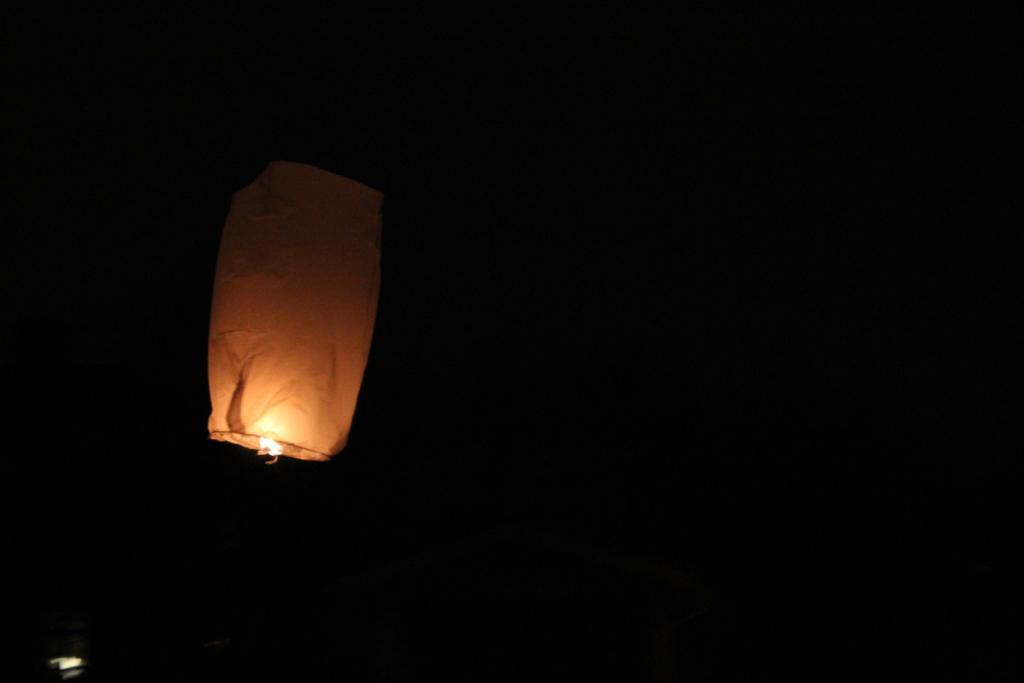Describe this image in one or two sentences. In this picture we can see a sky lantern. Background is black in color. 